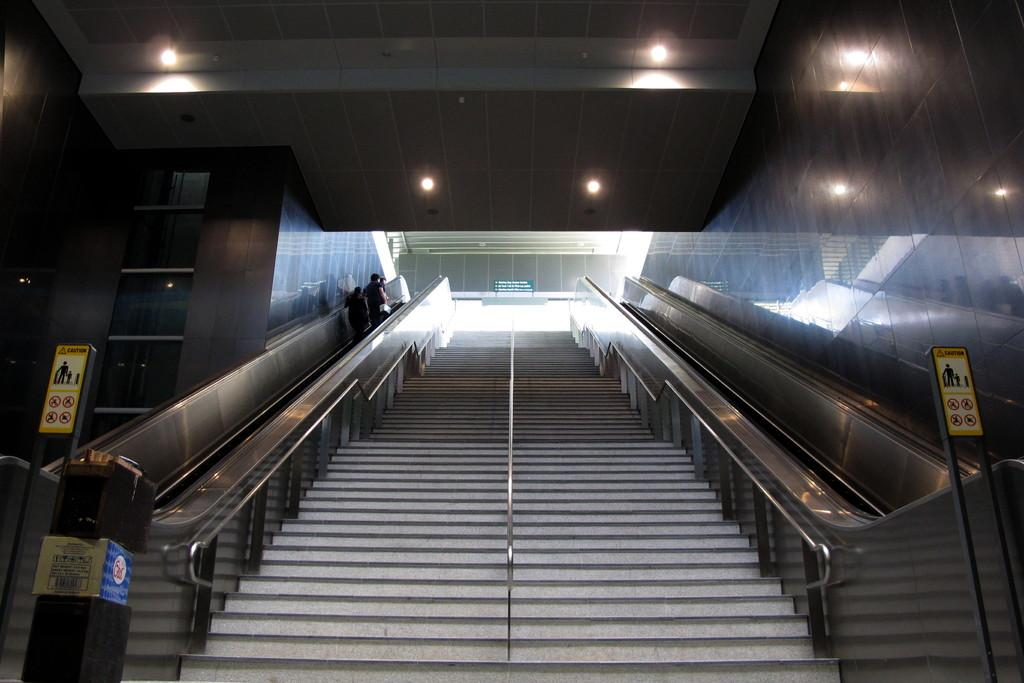What type of architectural feature is present in the image? There are steps in the image. What are people doing in the image? People are moving on an escalator in the image. Where is the escalator located in the image? The escalator is on the left side of the image. What can be seen in the background of the image? Boards and ceiling lights are visible in the background of the image. What type of linen is being used by the spy in the wilderness in the image? There is no spy or wilderness present in the image; it features steps, an escalator, and people moving on it. 